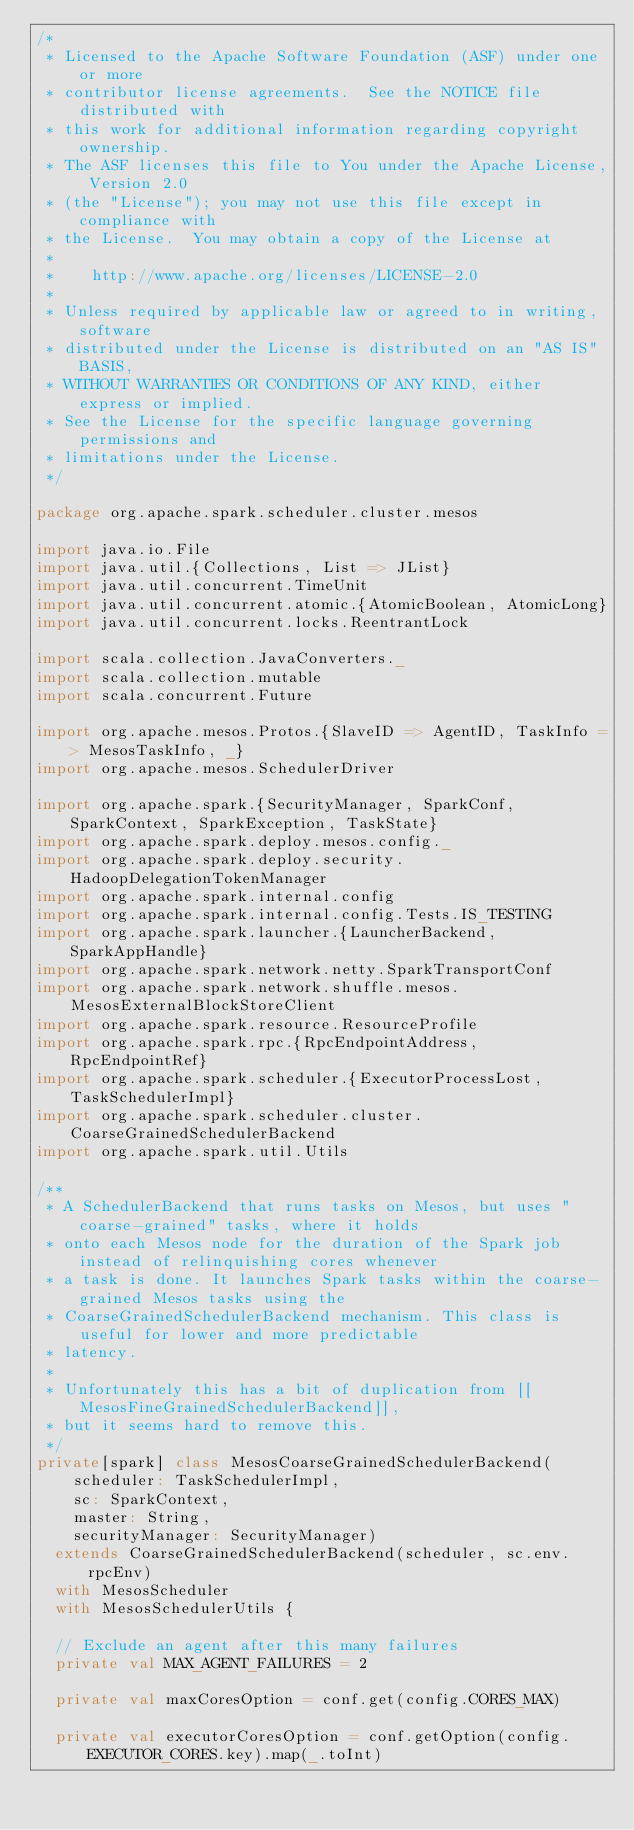<code> <loc_0><loc_0><loc_500><loc_500><_Scala_>/*
 * Licensed to the Apache Software Foundation (ASF) under one or more
 * contributor license agreements.  See the NOTICE file distributed with
 * this work for additional information regarding copyright ownership.
 * The ASF licenses this file to You under the Apache License, Version 2.0
 * (the "License"); you may not use this file except in compliance with
 * the License.  You may obtain a copy of the License at
 *
 *    http://www.apache.org/licenses/LICENSE-2.0
 *
 * Unless required by applicable law or agreed to in writing, software
 * distributed under the License is distributed on an "AS IS" BASIS,
 * WITHOUT WARRANTIES OR CONDITIONS OF ANY KIND, either express or implied.
 * See the License for the specific language governing permissions and
 * limitations under the License.
 */

package org.apache.spark.scheduler.cluster.mesos

import java.io.File
import java.util.{Collections, List => JList}
import java.util.concurrent.TimeUnit
import java.util.concurrent.atomic.{AtomicBoolean, AtomicLong}
import java.util.concurrent.locks.ReentrantLock

import scala.collection.JavaConverters._
import scala.collection.mutable
import scala.concurrent.Future

import org.apache.mesos.Protos.{SlaveID => AgentID, TaskInfo => MesosTaskInfo, _}
import org.apache.mesos.SchedulerDriver

import org.apache.spark.{SecurityManager, SparkConf, SparkContext, SparkException, TaskState}
import org.apache.spark.deploy.mesos.config._
import org.apache.spark.deploy.security.HadoopDelegationTokenManager
import org.apache.spark.internal.config
import org.apache.spark.internal.config.Tests.IS_TESTING
import org.apache.spark.launcher.{LauncherBackend, SparkAppHandle}
import org.apache.spark.network.netty.SparkTransportConf
import org.apache.spark.network.shuffle.mesos.MesosExternalBlockStoreClient
import org.apache.spark.resource.ResourceProfile
import org.apache.spark.rpc.{RpcEndpointAddress, RpcEndpointRef}
import org.apache.spark.scheduler.{ExecutorProcessLost, TaskSchedulerImpl}
import org.apache.spark.scheduler.cluster.CoarseGrainedSchedulerBackend
import org.apache.spark.util.Utils

/**
 * A SchedulerBackend that runs tasks on Mesos, but uses "coarse-grained" tasks, where it holds
 * onto each Mesos node for the duration of the Spark job instead of relinquishing cores whenever
 * a task is done. It launches Spark tasks within the coarse-grained Mesos tasks using the
 * CoarseGrainedSchedulerBackend mechanism. This class is useful for lower and more predictable
 * latency.
 *
 * Unfortunately this has a bit of duplication from [[MesosFineGrainedSchedulerBackend]],
 * but it seems hard to remove this.
 */
private[spark] class MesosCoarseGrainedSchedulerBackend(
    scheduler: TaskSchedulerImpl,
    sc: SparkContext,
    master: String,
    securityManager: SecurityManager)
  extends CoarseGrainedSchedulerBackend(scheduler, sc.env.rpcEnv)
  with MesosScheduler
  with MesosSchedulerUtils {

  // Exclude an agent after this many failures
  private val MAX_AGENT_FAILURES = 2

  private val maxCoresOption = conf.get(config.CORES_MAX)

  private val executorCoresOption = conf.getOption(config.EXECUTOR_CORES.key).map(_.toInt)
</code> 